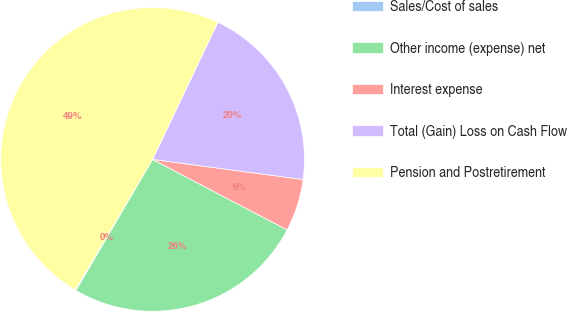<chart> <loc_0><loc_0><loc_500><loc_500><pie_chart><fcel>Sales/Cost of sales<fcel>Other income (expense) net<fcel>Interest expense<fcel>Total (Gain) Loss on Cash Flow<fcel>Pension and Postretirement<nl><fcel>0.11%<fcel>25.72%<fcel>5.57%<fcel>20.04%<fcel>48.55%<nl></chart> 